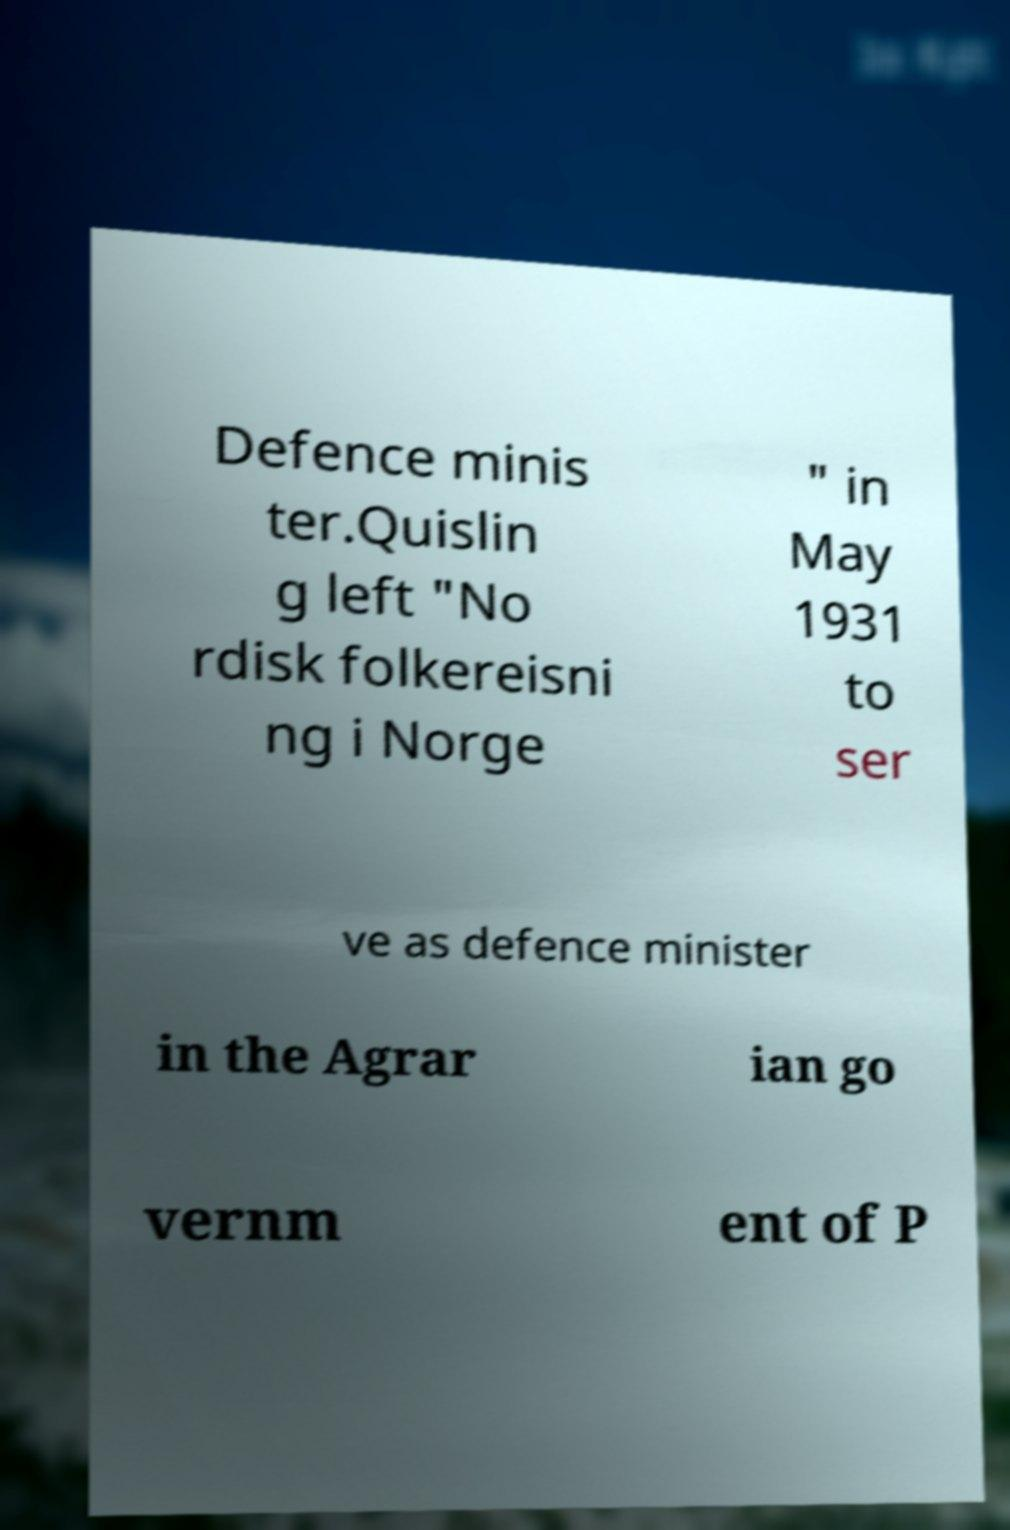Please identify and transcribe the text found in this image. Defence minis ter.Quislin g left "No rdisk folkereisni ng i Norge " in May 1931 to ser ve as defence minister in the Agrar ian go vernm ent of P 